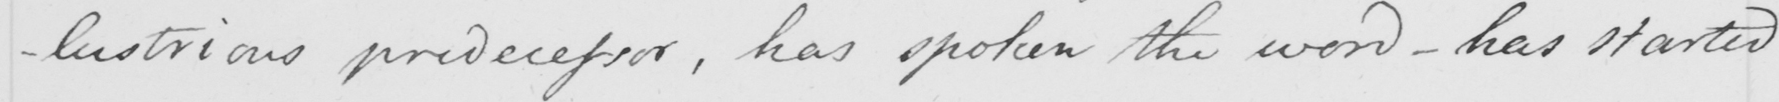Please provide the text content of this handwritten line. -lustrious predecessor , has spoken the word  _  has started 